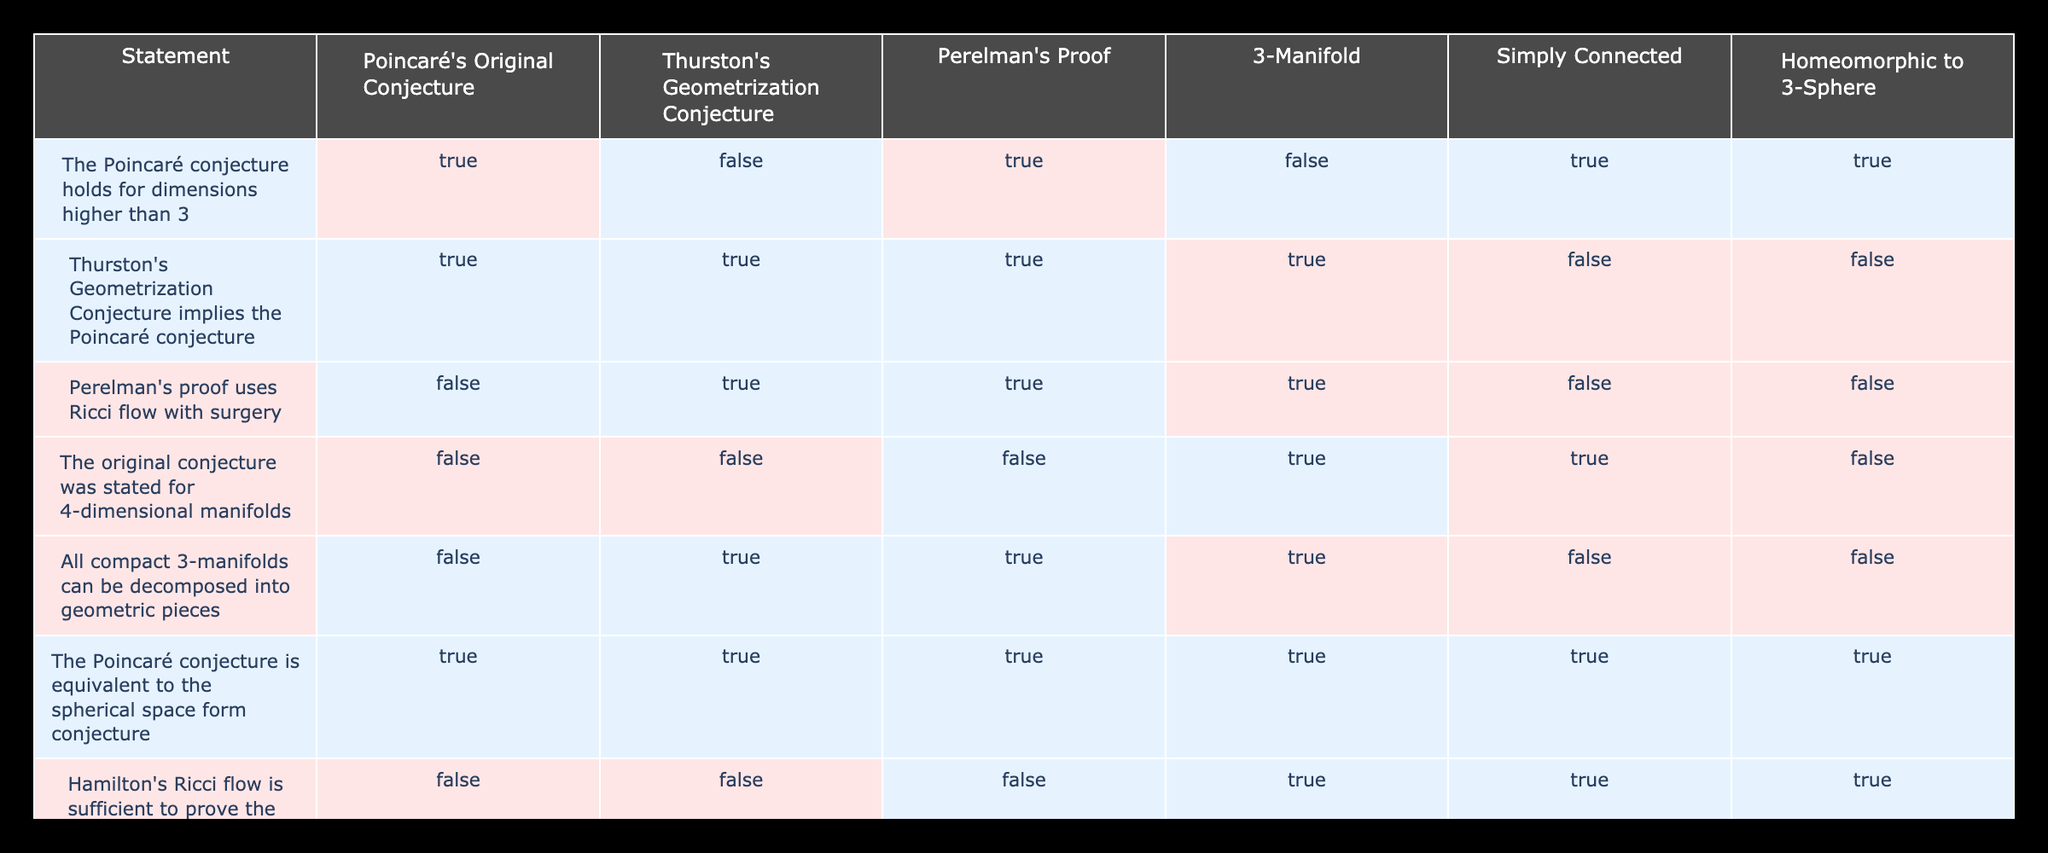What are the truth values for "The Poincaré conjecture holds for dimensions higher than 3"? From the table, the row corresponding to this statement shows TRUE for Poincaré's Original Conjecture and Perelman's Proof, but FALSE for Thurston's Geometrization Conjecture, 3-Manifold, and Homeomorphic to 3-Sphere.
Answer: TRUE, FALSE, TRUE, FALSE, TRUE, TRUE Is Thurston's Geometrization Conjecture equivalent to the Poincaré conjecture? The table indicates that the statement "Thurston's Geometrization Conjecture implies the Poincaré conjecture" yields TRUE for both conjectures, meaning they hold similar truth values in this context.
Answer: TRUE, TRUE What is the number of statements that are TRUE concerning the Poincaré conjecture? By reviewing the rows in the table, there are a total of 6 statements marked TRUE.
Answer: 6 Which statement has the highest number of TRUE values in the columns? Comparing the rows, the statement "The Poincaré conjecture is equivalent to the spherical space form conjecture" has TRUE values in all columns.
Answer: 1 Does Hamilton's Ricci flow suffices to prove the conjecture without modifications? Looking at the table, this statement is marked FALSE under all circumstances.
Answer: FALSE What is the relationship between the original conjecture and 4-dimensional manifolds? The table shows that the statement "The original conjecture was stated for 4-dimensional manifolds" is marked FALSE in relation to Poincaré's Original Conjecture, Thurston's Geometrization Conjecture, and Perelman's Proof, indicating they do not support this view.
Answer: FALSE How many statements are TRUE for simply connected 3-manifolds? By counting the TRUE values in the "Simply Connected" column, we find there are 3 statements that hold true.
Answer: 3 What can be inferred about the truth of the conjecture for non-simply connected manifolds? The table states that the conjecture does not hold true for non-simply connected manifolds, as indicated by the overall FALSE values in that row across all conjectures.
Answer: FALSE How does the truth of Perelman's proof compare with the Poincaré conjecture for 3-manifolds? From the table, we see that Perelman's proof is TRUE for the case of 3-manifolds, reinforcing that it maintains the integrity of the conjecture in that specific dimension.
Answer: TRUE 